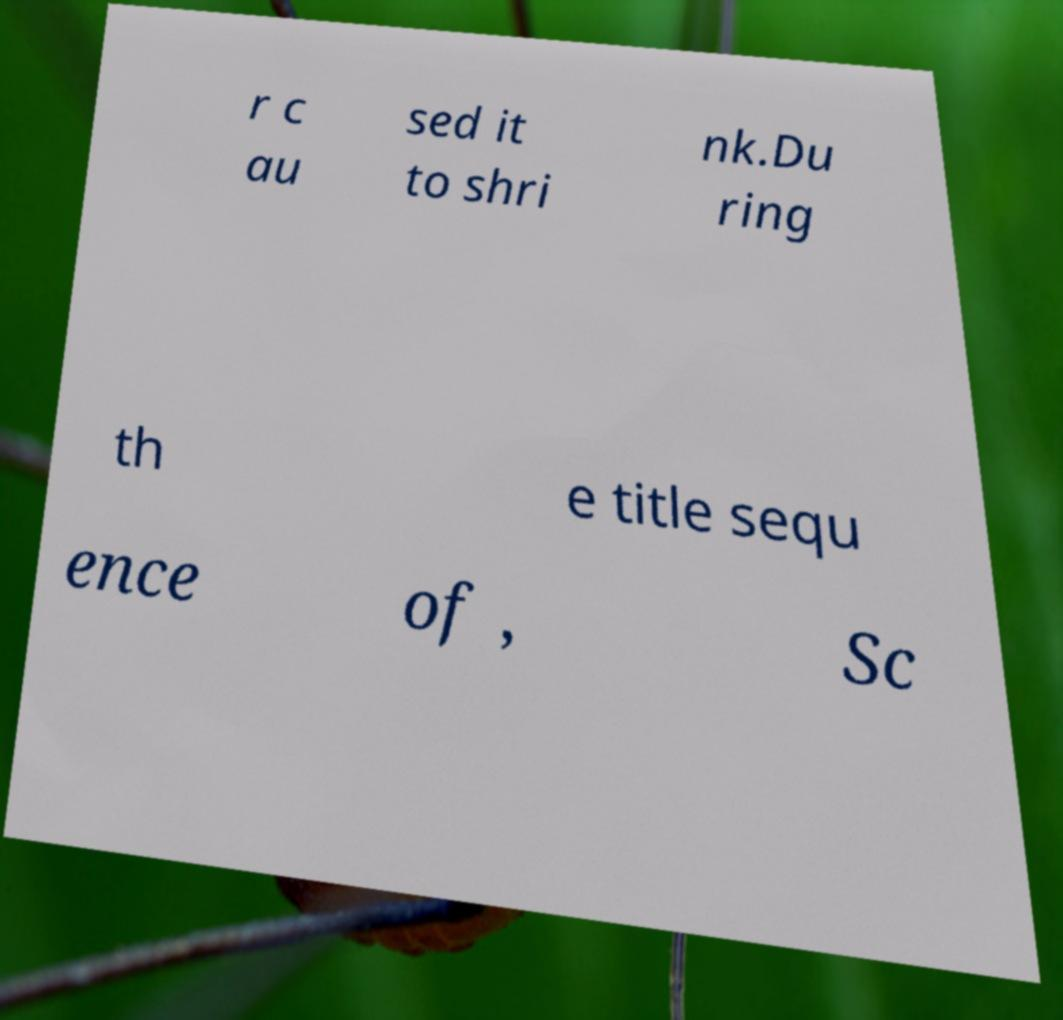What messages or text are displayed in this image? I need them in a readable, typed format. r c au sed it to shri nk.Du ring th e title sequ ence of , Sc 